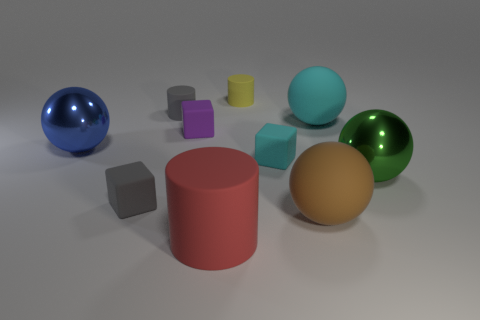Does the gray cylinder have the same size as the brown sphere?
Your response must be concise. No. What number of other things are there of the same shape as the green metallic object?
Make the answer very short. 3. The tiny cyan object that is behind the large rubber cylinder has what shape?
Provide a short and direct response. Cube. There is a small matte object that is to the right of the small yellow object; is it the same shape as the gray thing in front of the small cyan matte block?
Your answer should be very brief. Yes. Is the number of rubber things to the left of the yellow matte cylinder the same as the number of spheres?
Offer a very short reply. Yes. There is a big green thing that is the same shape as the brown object; what material is it?
Offer a very short reply. Metal. What is the shape of the gray matte thing that is behind the cube on the right side of the small yellow matte thing?
Provide a short and direct response. Cylinder. Is the material of the big thing that is behind the blue metal ball the same as the blue ball?
Give a very brief answer. No. Are there an equal number of yellow matte objects that are to the left of the red rubber cylinder and tiny matte blocks right of the tiny purple matte block?
Your answer should be very brief. No. How many tiny matte cubes are in front of the large metallic object behind the tiny cyan block?
Make the answer very short. 2. 